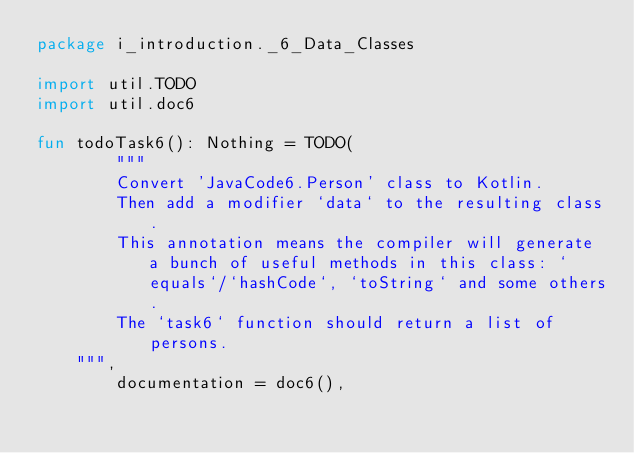<code> <loc_0><loc_0><loc_500><loc_500><_Kotlin_>package i_introduction._6_Data_Classes

import util.TODO
import util.doc6

fun todoTask6(): Nothing = TODO(
        """
        Convert 'JavaCode6.Person' class to Kotlin.
        Then add a modifier `data` to the resulting class.
        This annotation means the compiler will generate a bunch of useful methods in this class: `equals`/`hashCode`, `toString` and some others.
        The `task6` function should return a list of persons.
    """,
        documentation = doc6(),</code> 